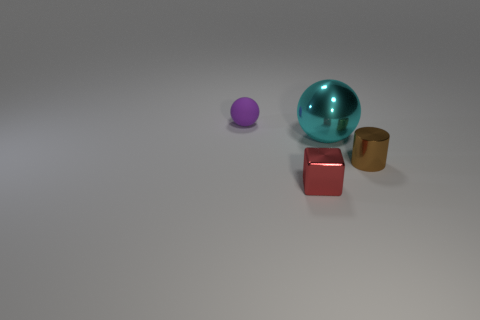What is the material of the small purple sphere?
Keep it short and to the point. Rubber. Is the purple rubber object the same size as the cube?
Keep it short and to the point. Yes. How many balls are either green matte objects or big metallic objects?
Offer a very short reply. 1. There is a metallic thing that is left of the ball that is in front of the purple matte thing; what color is it?
Provide a short and direct response. Red. Is the number of small spheres on the right side of the cyan sphere less than the number of small red metal blocks that are in front of the small purple rubber ball?
Make the answer very short. Yes. Do the brown metallic cylinder and the sphere to the right of the tiny red object have the same size?
Offer a very short reply. No. The metallic object that is both in front of the large cyan shiny thing and to the right of the red cube has what shape?
Provide a succinct answer. Cylinder. There is a ball that is made of the same material as the red block; what size is it?
Offer a terse response. Large. There is a shiny object that is to the right of the large cyan thing; what number of tiny purple rubber balls are on the left side of it?
Give a very brief answer. 1. Is the sphere on the right side of the purple matte ball made of the same material as the brown cylinder?
Your answer should be very brief. Yes. 